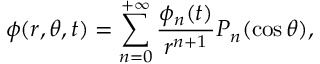<formula> <loc_0><loc_0><loc_500><loc_500>\phi ( r , \theta , t ) = \sum _ { n = 0 } ^ { + \infty } \frac { \phi _ { n } ( t ) } { r ^ { n + 1 } } P _ { n } ( \cos \theta ) ,</formula> 